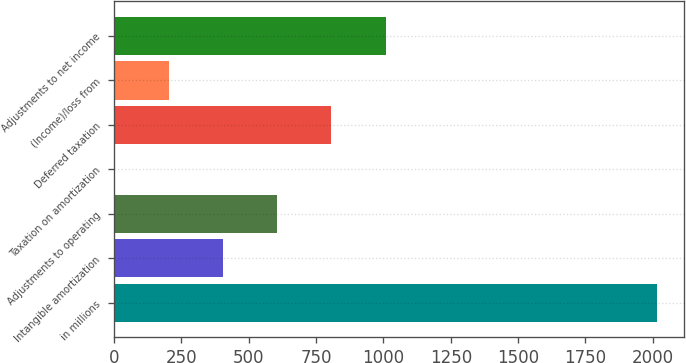Convert chart. <chart><loc_0><loc_0><loc_500><loc_500><bar_chart><fcel>in millions<fcel>Intangible amortization<fcel>Adjustments to operating<fcel>Taxation on amortization<fcel>Deferred taxation<fcel>(Income)/loss from<fcel>Adjustments to net income<nl><fcel>2014<fcel>404.08<fcel>605.32<fcel>1.6<fcel>806.56<fcel>202.84<fcel>1007.8<nl></chart> 